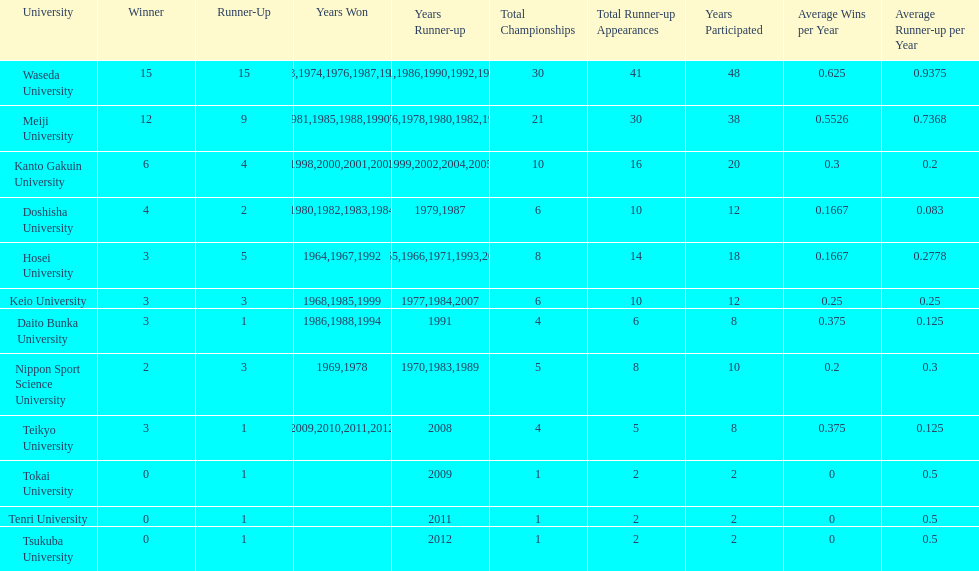Which university had the most years won? Waseda University. 